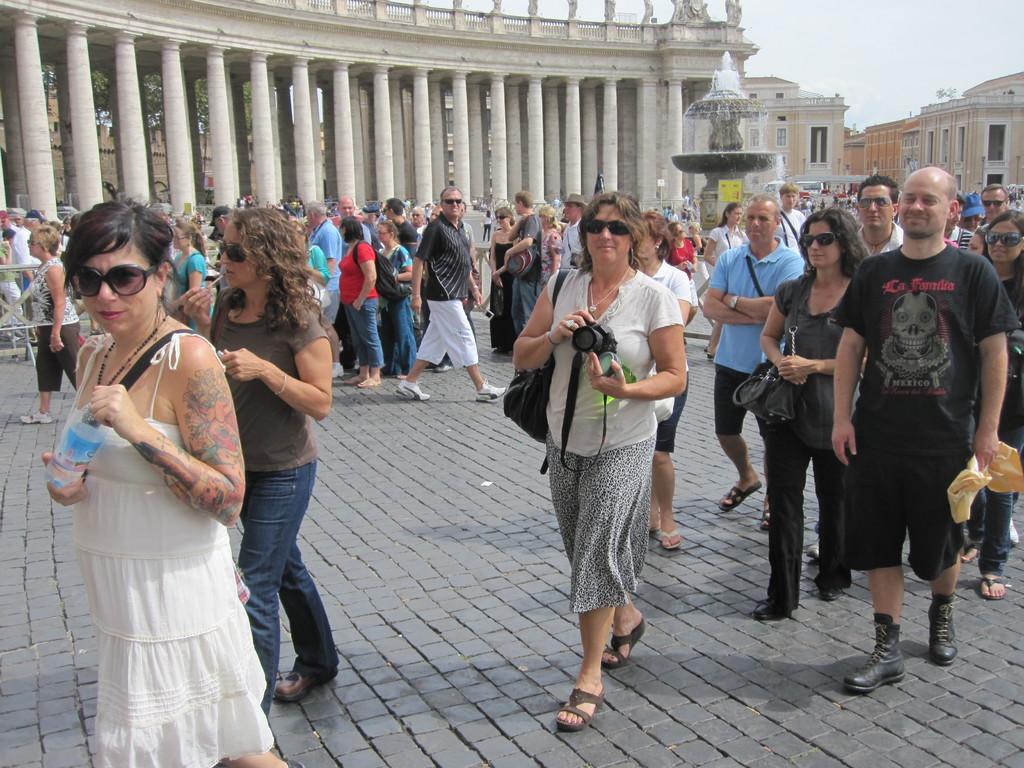Can you describe this image briefly? In this image there are a few people standing and walking on the road and there is a fountain. In the background there are buildings and the sky. 